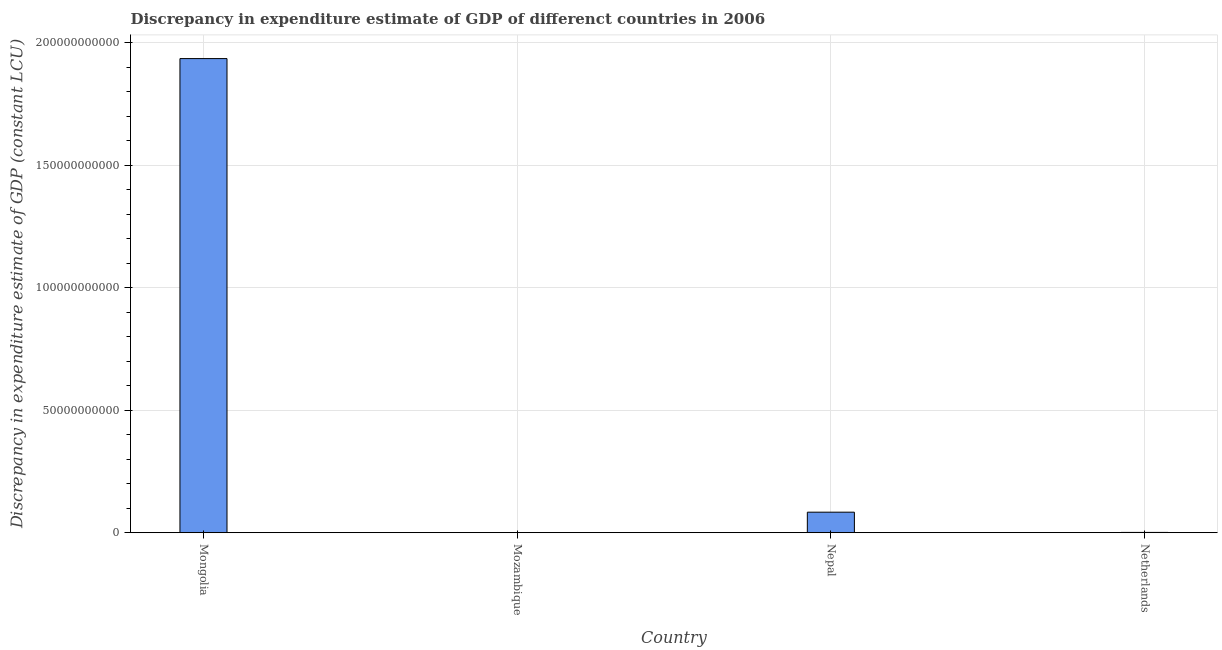Does the graph contain any zero values?
Provide a short and direct response. Yes. Does the graph contain grids?
Keep it short and to the point. Yes. What is the title of the graph?
Make the answer very short. Discrepancy in expenditure estimate of GDP of differenct countries in 2006. What is the label or title of the X-axis?
Your answer should be compact. Country. What is the label or title of the Y-axis?
Your response must be concise. Discrepancy in expenditure estimate of GDP (constant LCU). What is the discrepancy in expenditure estimate of gdp in Netherlands?
Offer a terse response. 1.21e+08. Across all countries, what is the maximum discrepancy in expenditure estimate of gdp?
Ensure brevity in your answer.  1.93e+11. Across all countries, what is the minimum discrepancy in expenditure estimate of gdp?
Your answer should be very brief. 0. In which country was the discrepancy in expenditure estimate of gdp maximum?
Offer a terse response. Mongolia. What is the sum of the discrepancy in expenditure estimate of gdp?
Your response must be concise. 2.02e+11. What is the difference between the discrepancy in expenditure estimate of gdp in Mongolia and Netherlands?
Your response must be concise. 1.93e+11. What is the average discrepancy in expenditure estimate of gdp per country?
Your answer should be very brief. 5.05e+1. What is the median discrepancy in expenditure estimate of gdp?
Offer a very short reply. 4.25e+09. What is the ratio of the discrepancy in expenditure estimate of gdp in Mongolia to that in Nepal?
Your answer should be compact. 23.09. Is the difference between the discrepancy in expenditure estimate of gdp in Mongolia and Nepal greater than the difference between any two countries?
Make the answer very short. No. What is the difference between the highest and the second highest discrepancy in expenditure estimate of gdp?
Ensure brevity in your answer.  1.85e+11. What is the difference between the highest and the lowest discrepancy in expenditure estimate of gdp?
Ensure brevity in your answer.  1.93e+11. How many countries are there in the graph?
Provide a succinct answer. 4. What is the difference between two consecutive major ticks on the Y-axis?
Provide a succinct answer. 5.00e+1. Are the values on the major ticks of Y-axis written in scientific E-notation?
Provide a succinct answer. No. What is the Discrepancy in expenditure estimate of GDP (constant LCU) of Mongolia?
Your answer should be very brief. 1.93e+11. What is the Discrepancy in expenditure estimate of GDP (constant LCU) in Mozambique?
Your answer should be compact. 0. What is the Discrepancy in expenditure estimate of GDP (constant LCU) of Nepal?
Ensure brevity in your answer.  8.38e+09. What is the Discrepancy in expenditure estimate of GDP (constant LCU) in Netherlands?
Your response must be concise. 1.21e+08. What is the difference between the Discrepancy in expenditure estimate of GDP (constant LCU) in Mongolia and Nepal?
Ensure brevity in your answer.  1.85e+11. What is the difference between the Discrepancy in expenditure estimate of GDP (constant LCU) in Mongolia and Netherlands?
Your response must be concise. 1.93e+11. What is the difference between the Discrepancy in expenditure estimate of GDP (constant LCU) in Nepal and Netherlands?
Give a very brief answer. 8.26e+09. What is the ratio of the Discrepancy in expenditure estimate of GDP (constant LCU) in Mongolia to that in Nepal?
Your answer should be compact. 23.09. What is the ratio of the Discrepancy in expenditure estimate of GDP (constant LCU) in Mongolia to that in Netherlands?
Your answer should be compact. 1602.73. What is the ratio of the Discrepancy in expenditure estimate of GDP (constant LCU) in Nepal to that in Netherlands?
Your response must be concise. 69.41. 